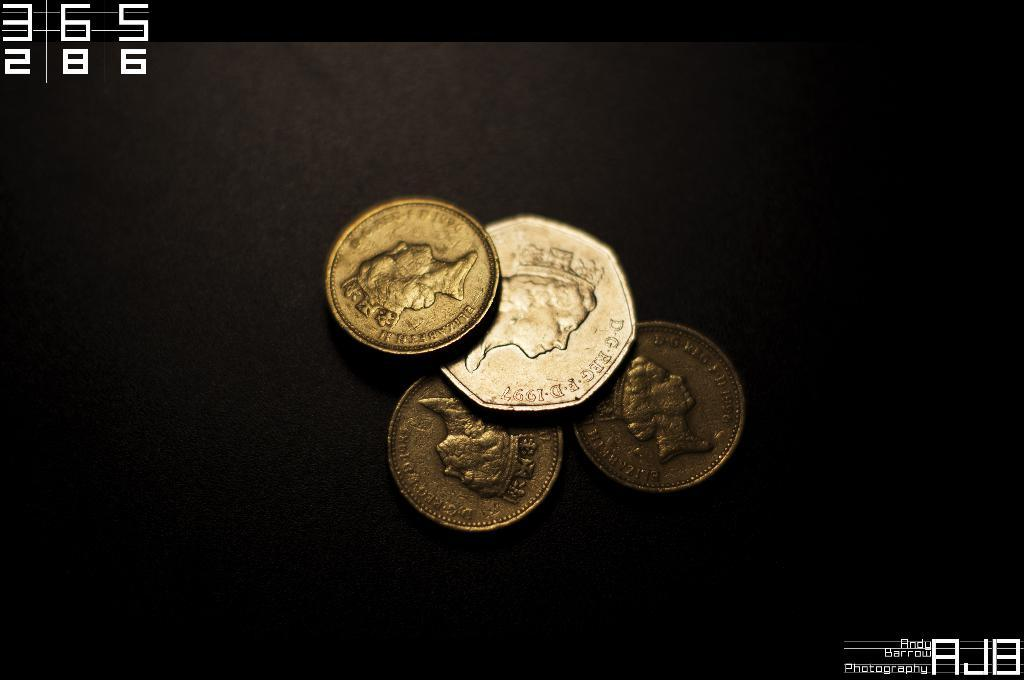<image>
Render a clear and concise summary of the photo. Four golden looking coins have the Queen on them and one is minted in 1997. 